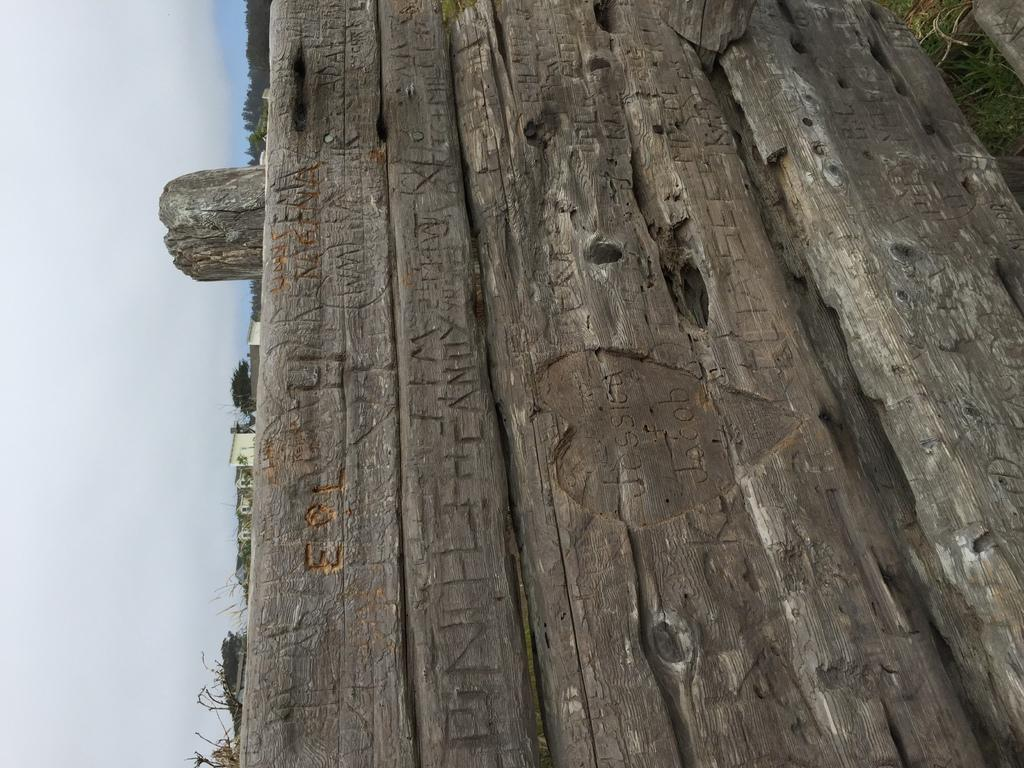What objects are present in the image? There are wood logs in the image. What is written or printed on the wood logs? There is text on the wood logs. What can be seen in the background of the image? There is a group of trees and the sky visible in the background of the image. What is the purpose of the office in the image? There is no office present in the image; it features wood logs with text and a background of trees and the sky. 